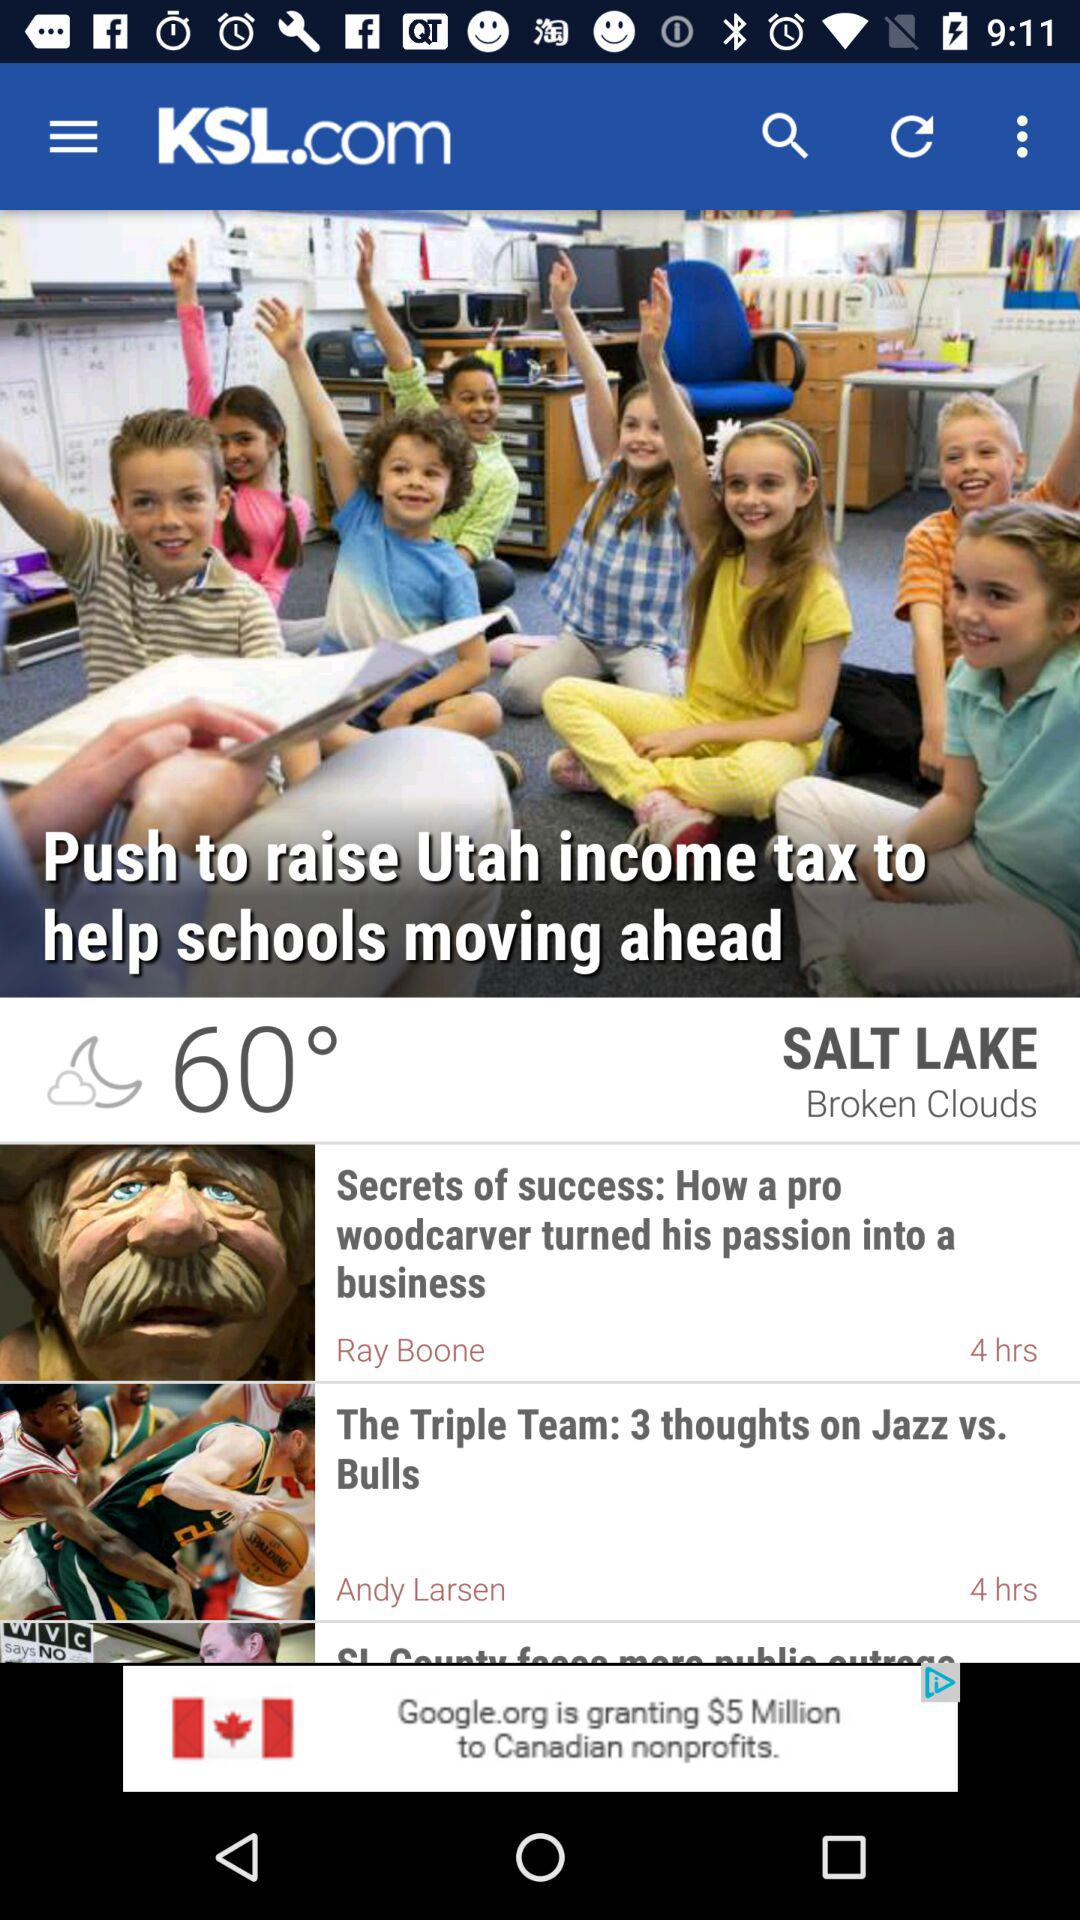What is the headline of the article written by Ray Boone? The headline of the article is "Secrets of success: How a pro woodcarver turned his passion into a business". 